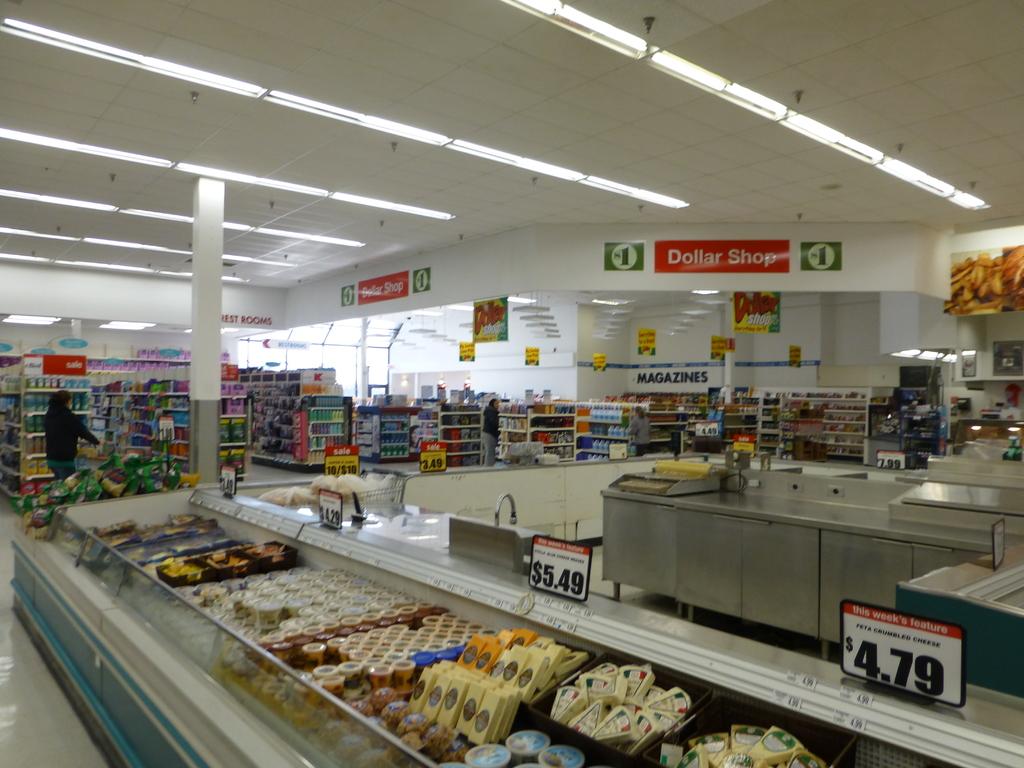What price is shown on the right?
Your answer should be compact. 4.79. 